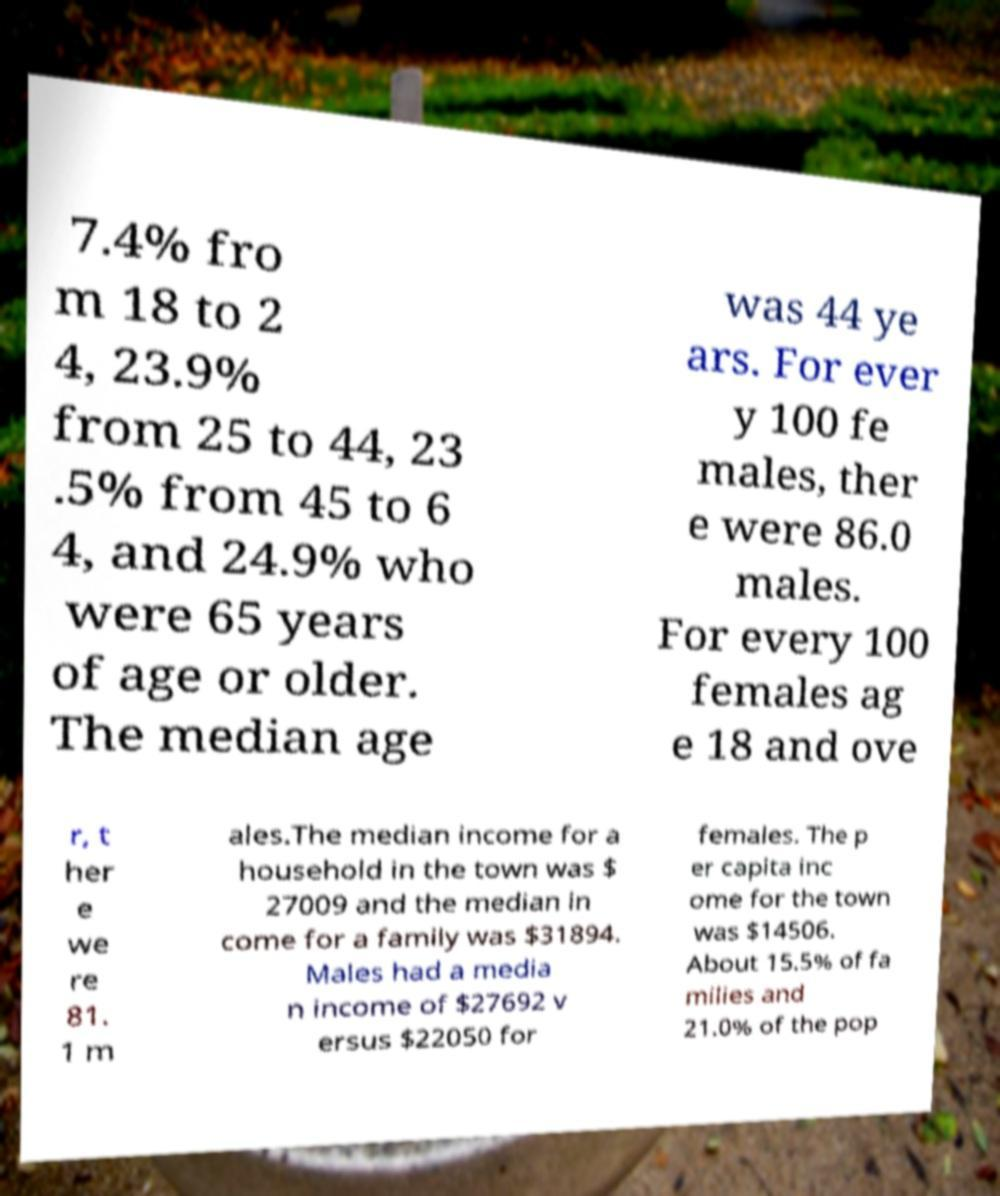There's text embedded in this image that I need extracted. Can you transcribe it verbatim? 7.4% fro m 18 to 2 4, 23.9% from 25 to 44, 23 .5% from 45 to 6 4, and 24.9% who were 65 years of age or older. The median age was 44 ye ars. For ever y 100 fe males, ther e were 86.0 males. For every 100 females ag e 18 and ove r, t her e we re 81. 1 m ales.The median income for a household in the town was $ 27009 and the median in come for a family was $31894. Males had a media n income of $27692 v ersus $22050 for females. The p er capita inc ome for the town was $14506. About 15.5% of fa milies and 21.0% of the pop 